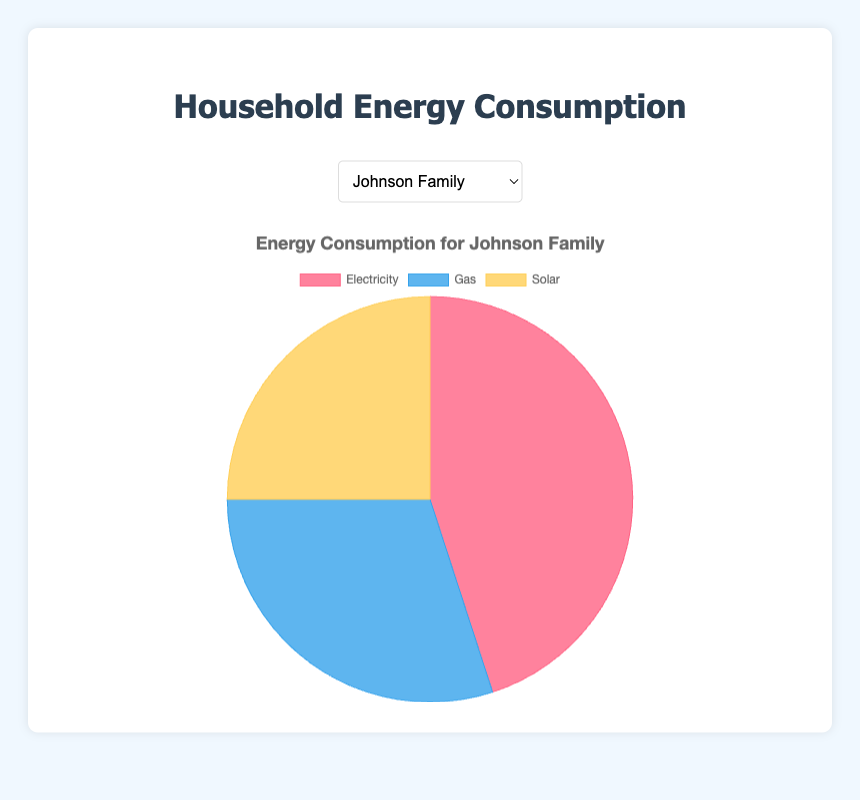What's the largest energy source for the Johnson Family? Based on the pie chart for the Johnson Family, the largest portion falls under "Electricity"
Answer: Electricity Which household consumes the least amount of solar energy? By comparing the solar energy proportions in the pie charts of all households, the Davis Residence, Garcia Family, and Martinez Household each have the smallest slice for solar energy at 10 units
Answer: Davis Residence, Garcia Family, and Martinez Household What is the combined consumption of electricity and gas for the Smith Household? In the Smith Household's pie chart, electricity consumption is 60 units and gas consumption is 20 units. Adding them up gives 60 + 20 = 80 units
Answer: 80 units Which household has the highest reliance on gas energy? Reviewing the pie charts and looking at the gas segment, the Davis Residence has the largest portion, consuming 40 units of gas
Answer: Davis Residence Which energy source is the smallest for Martinez Household? Looking at the pie chart for the Martinez Household, the smallest slice represents "Solar" with a consumption of 10 units
Answer: Solar What is the ratio of electricity to solar energy consumption for the Garcia Family? In the Garcia Family's pie chart, electricity consumption is 55 units and solar consumption is 10 units. The ratio is 55:10, or simplified, 5.5:1
Answer: 5.5:1 How does the average energy consumption from solar across all households compare to the Johnson Family's solar consumption? Sum up the solar consumption across all households (25 + 20 + 10 + 10 + 10 = 75) and then divide by the number of households (75 / 5 = 15). Johnson Family’s solar consumption is 25, higher than the average.
Answer: Johnson Family’s solar consumption is higher Between the Smith Household and the Davis Residence, which one has a greater total energy consumption? Summing up energy consumption for each: Smith Household (60 + 20 + 20 = 100), Davis Residence (50 + 40 + 10 = 100). Both have the same total energy consumption.
Answer: Both have the same If you combine gas consumption of Garcia Family and Martinez Household, what percentage of the total combined energy consumption (for both families) does it represent? Garcia Family’s gas consumption is 35, Martinez Household’s is 28. Total energy for Garcia (55+35+10 = 100) and Martinez (62+28+10 = 100). So, combined gas is 35+28 = 63, total combined energy is 200. Percentage is (63/200)*100 = 31.5%
Answer: 31.5% 